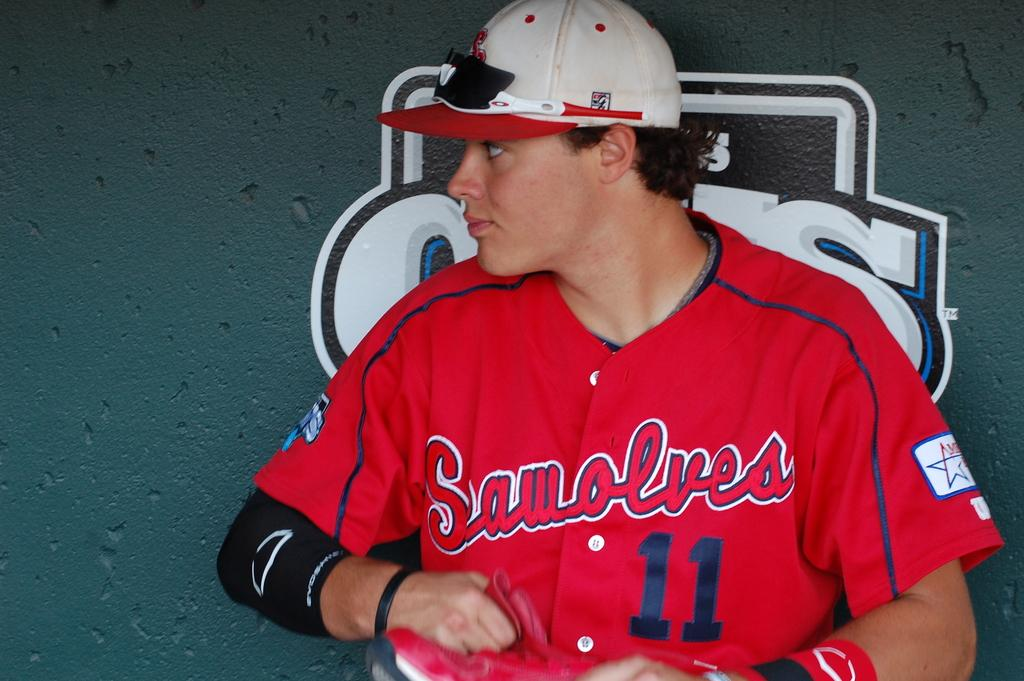<image>
Relay a brief, clear account of the picture shown. A man in a Sawolves baseball uniform stands against a wall. 